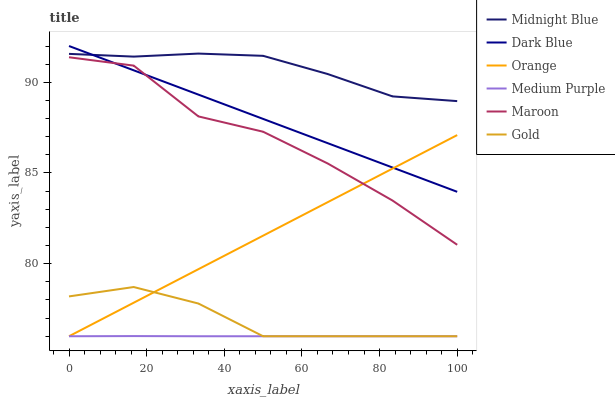Does Medium Purple have the minimum area under the curve?
Answer yes or no. Yes. Does Midnight Blue have the maximum area under the curve?
Answer yes or no. Yes. Does Gold have the minimum area under the curve?
Answer yes or no. No. Does Gold have the maximum area under the curve?
Answer yes or no. No. Is Orange the smoothest?
Answer yes or no. Yes. Is Maroon the roughest?
Answer yes or no. Yes. Is Gold the smoothest?
Answer yes or no. No. Is Gold the roughest?
Answer yes or no. No. Does Gold have the lowest value?
Answer yes or no. Yes. Does Maroon have the lowest value?
Answer yes or no. No. Does Dark Blue have the highest value?
Answer yes or no. Yes. Does Gold have the highest value?
Answer yes or no. No. Is Medium Purple less than Maroon?
Answer yes or no. Yes. Is Midnight Blue greater than Gold?
Answer yes or no. Yes. Does Medium Purple intersect Gold?
Answer yes or no. Yes. Is Medium Purple less than Gold?
Answer yes or no. No. Is Medium Purple greater than Gold?
Answer yes or no. No. Does Medium Purple intersect Maroon?
Answer yes or no. No. 